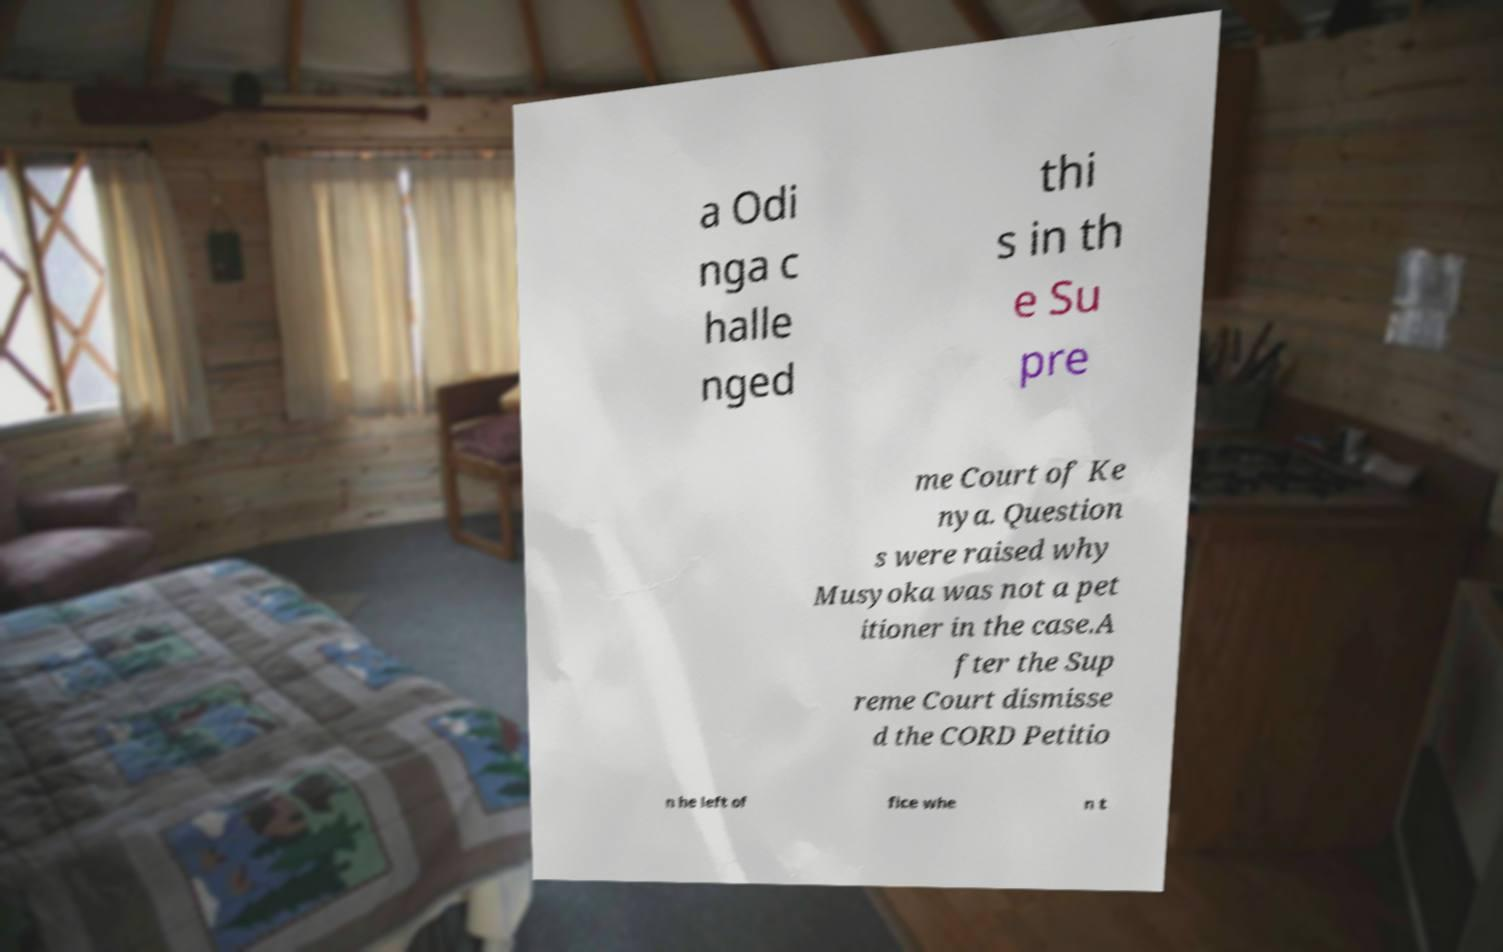Could you assist in decoding the text presented in this image and type it out clearly? a Odi nga c halle nged thi s in th e Su pre me Court of Ke nya. Question s were raised why Musyoka was not a pet itioner in the case.A fter the Sup reme Court dismisse d the CORD Petitio n he left of fice whe n t 